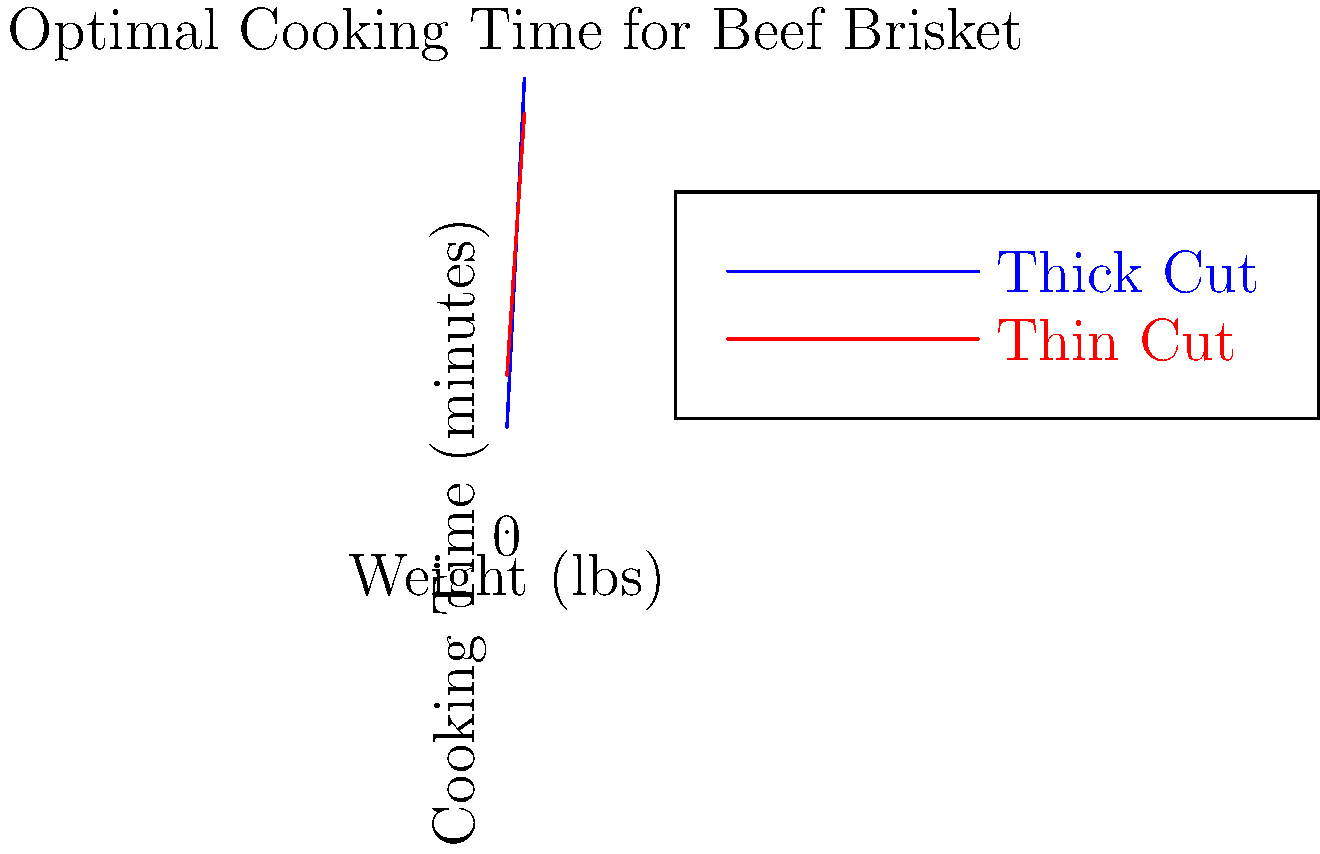As a barbecue enthusiast, you're preparing for a classic rock-themed cookout. Using the graph above, which shows the optimal cooking time for beef brisket based on weight and thickness, calculate the difference in cooking time between a thick-cut 4-pound brisket and a thin-cut 4-pound brisket. Express your answer in minutes. Let's approach this step-by-step:

1. For the thick-cut brisket:
   - The equation is $y = 20x + 30$, where $x$ is weight in pounds and $y$ is cooking time in minutes.
   - For a 4-pound brisket: $y = 20(4) + 30 = 80 + 30 = 110$ minutes

2. For the thin-cut brisket:
   - The equation is $y = 15x + 45$
   - For a 4-pound brisket: $y = 15(4) + 45 = 60 + 45 = 105$ minutes

3. To find the difference:
   - Thick-cut cooking time - Thin-cut cooking time
   - $110 - 105 = 5$ minutes

Therefore, the difference in cooking time between a thick-cut and thin-cut 4-pound brisket is 5 minutes.
Answer: 5 minutes 